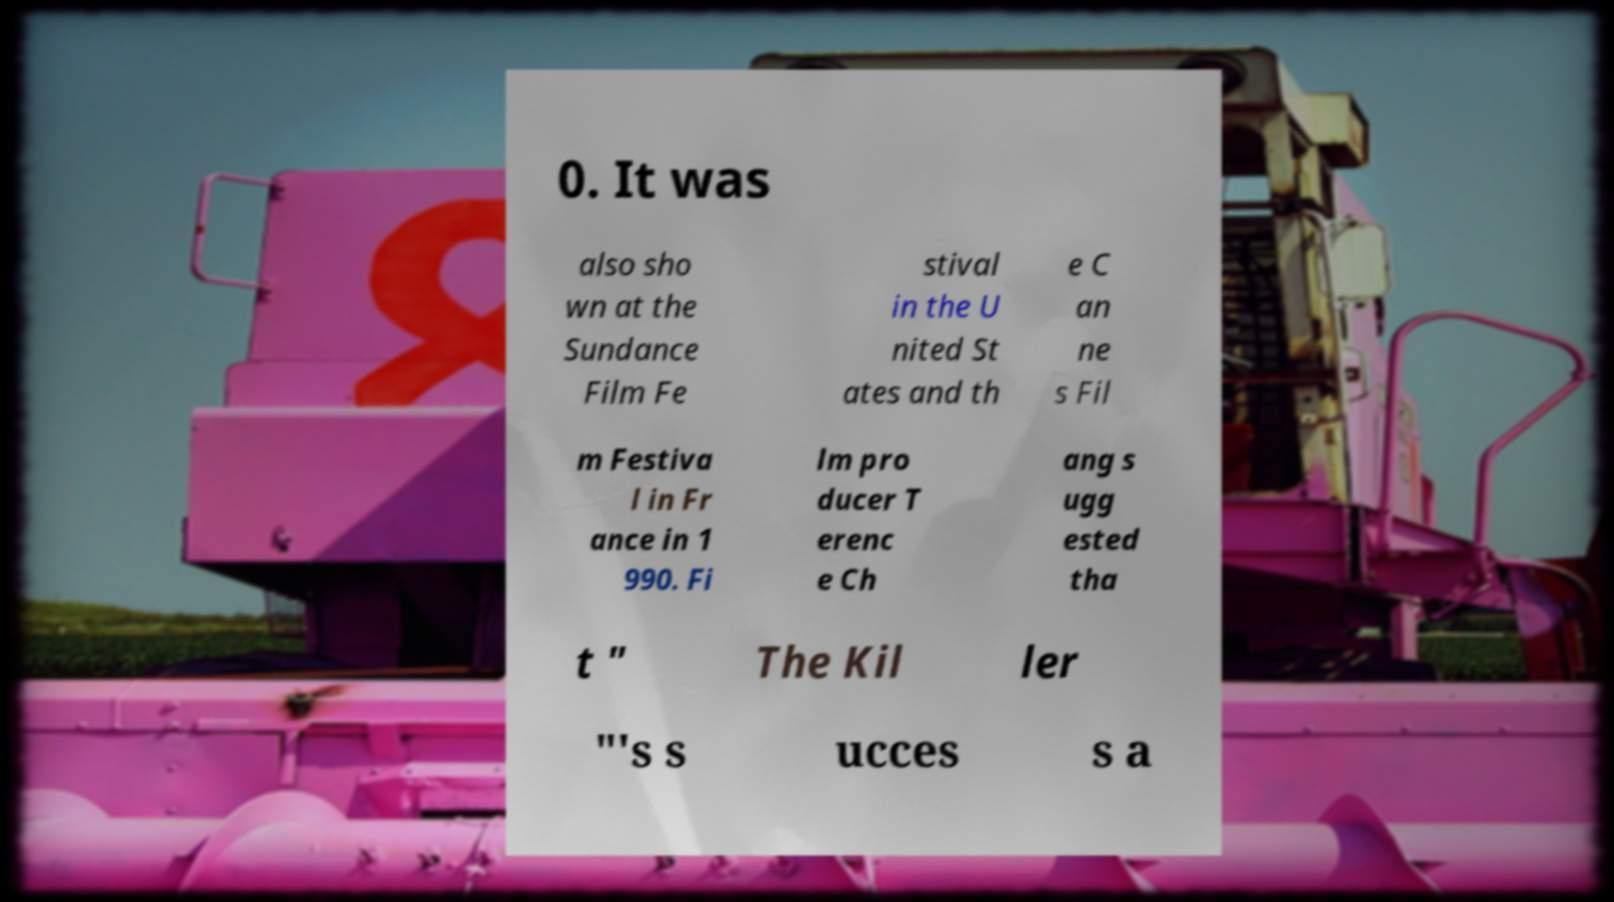I need the written content from this picture converted into text. Can you do that? 0. It was also sho wn at the Sundance Film Fe stival in the U nited St ates and th e C an ne s Fil m Festiva l in Fr ance in 1 990. Fi lm pro ducer T erenc e Ch ang s ugg ested tha t " The Kil ler "'s s ucces s a 